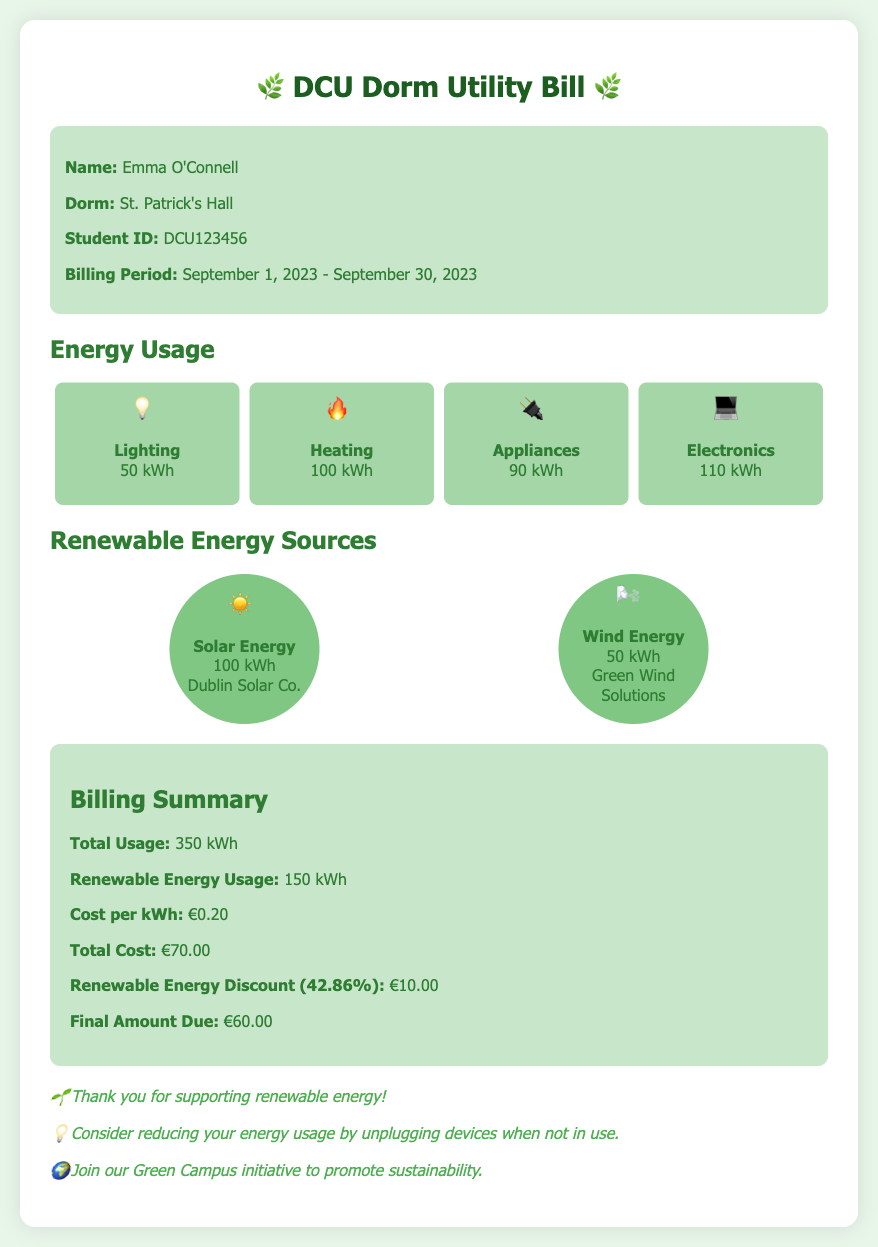What is the name of the student? The student's name is provided in the student info section.
Answer: Emma O'Connell What is the total energy usage? The total energy usage is mentioned in the billing summary section.
Answer: 350 kWh How much did the renewable energy discount amount to? The renewable energy discount is listed in the billing summary section.
Answer: €10.00 Which renewable energy source provided the most energy? The renewable energy sources section highlights the energy amounts.
Answer: Solar Energy What is the cost per kWh? The cost per kWh is stated in the billing summary.
Answer: €0.20 What dorm does the student live in? The student's dorm is included in the student info section.
Answer: St. Patrick's Hall How many kWh of Wind Energy was used? The renewable energy sources section includes this specific information.
Answer: 50 kWh What is the final amount due? The final amount due is mentioned in the billing summary section.
Answer: €60.00 What period does this billing cover? The billing period is specified in the student info section.
Answer: September 1, 2023 - September 30, 2023 